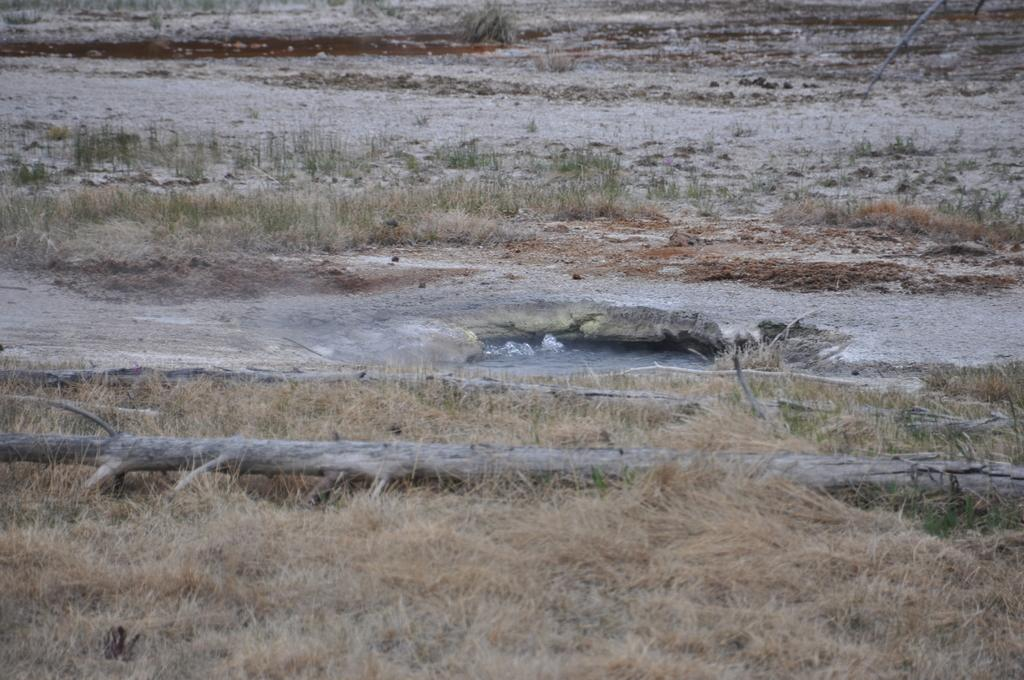What type of vegetation can be seen in the image? There is dried grass in the image. What else can be seen in the image besides the dried grass? There is water and a branch visible in the image. What day of the week is depicted in the image? The image does not depict a day of the week; it only shows dried grass, water, and a branch. 